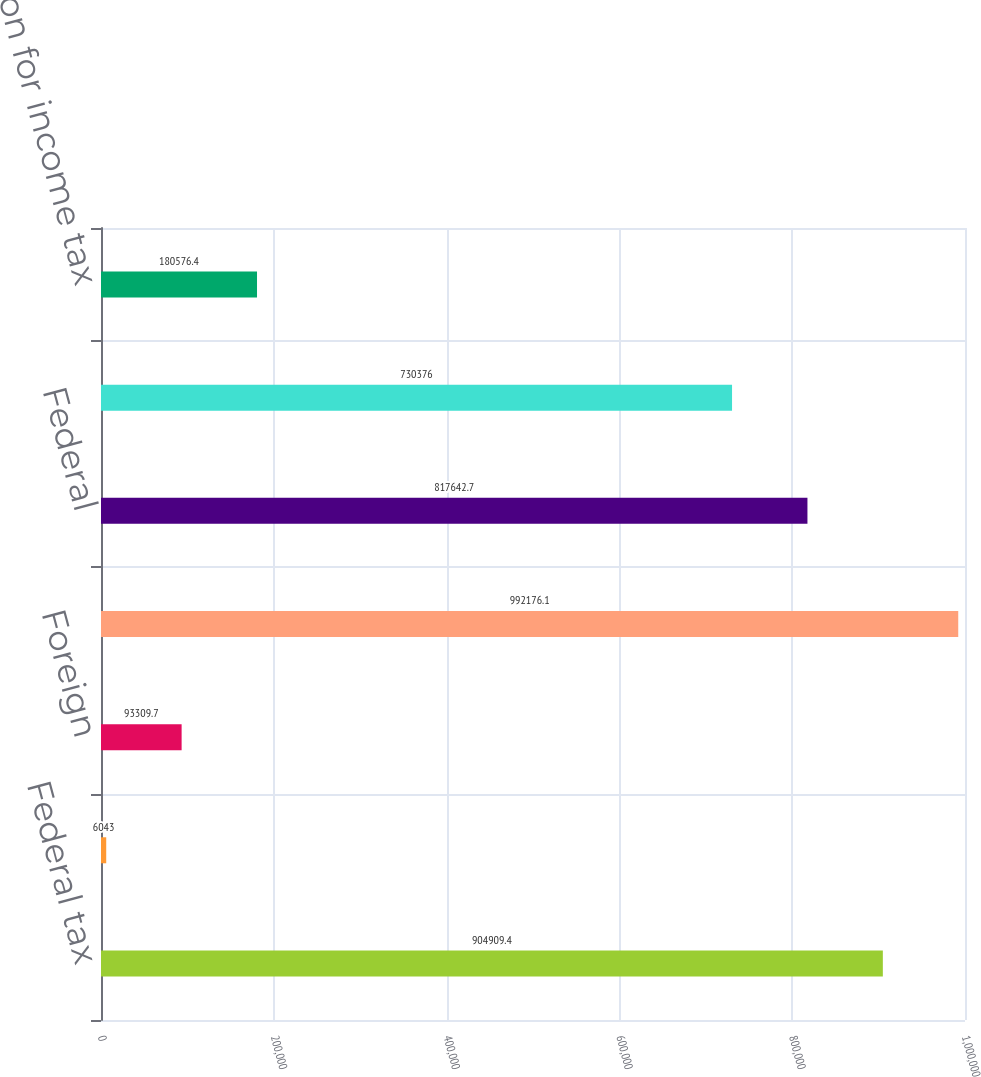Convert chart to OTSL. <chart><loc_0><loc_0><loc_500><loc_500><bar_chart><fcel>Federal tax<fcel>State<fcel>Foreign<fcel>Total current<fcel>Federal<fcel>Total deferre d<fcel>Provision for income tax<nl><fcel>904909<fcel>6043<fcel>93309.7<fcel>992176<fcel>817643<fcel>730376<fcel>180576<nl></chart> 